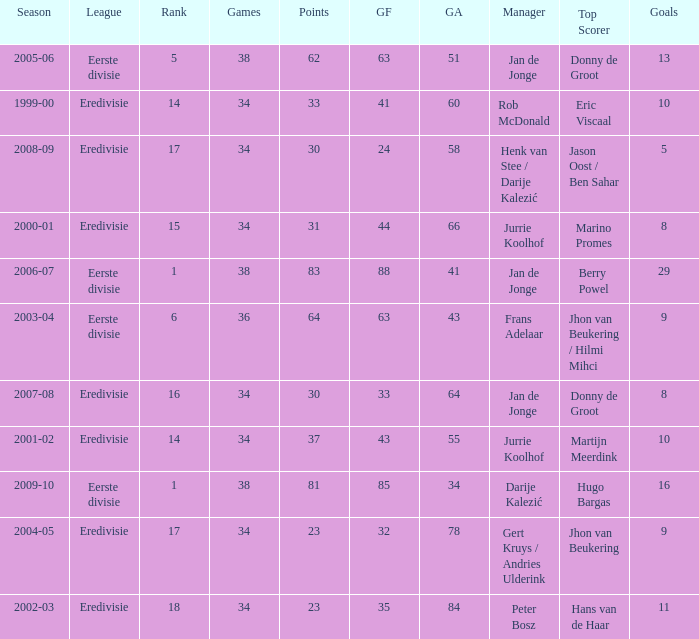How many goals were scored in the 2005-06 season? 13.0. 